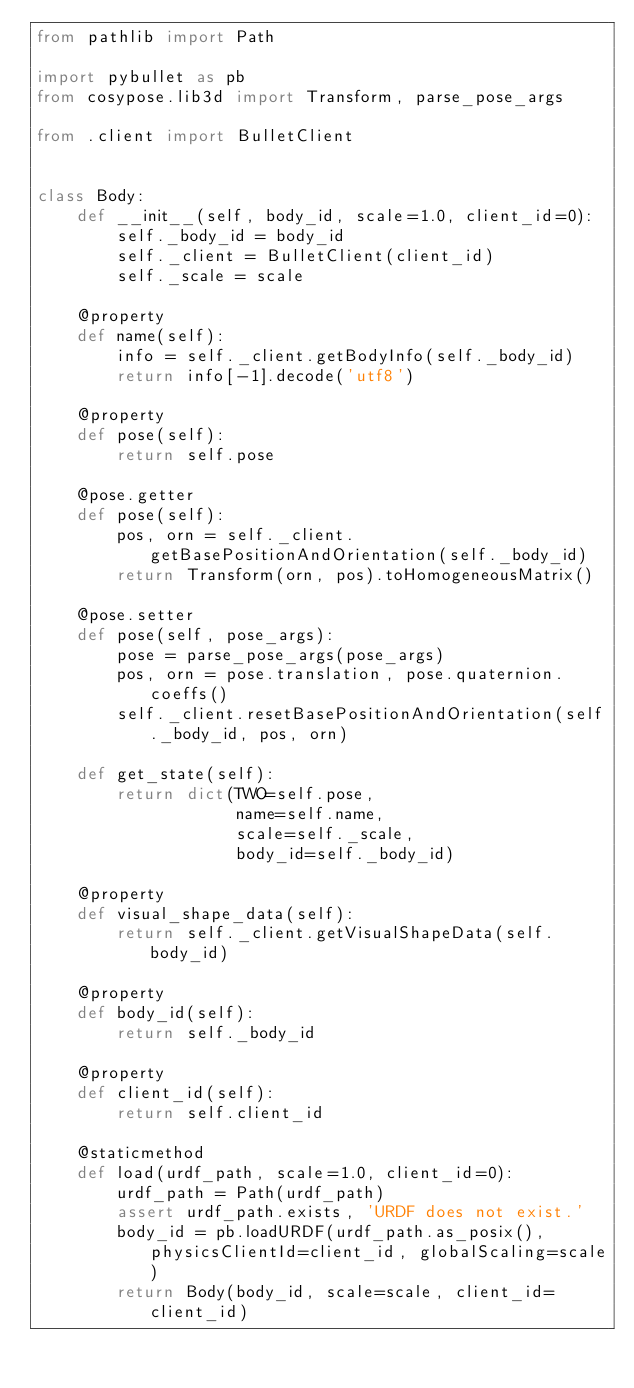<code> <loc_0><loc_0><loc_500><loc_500><_Python_>from pathlib import Path

import pybullet as pb
from cosypose.lib3d import Transform, parse_pose_args

from .client import BulletClient


class Body:
    def __init__(self, body_id, scale=1.0, client_id=0):
        self._body_id = body_id
        self._client = BulletClient(client_id)
        self._scale = scale

    @property
    def name(self):
        info = self._client.getBodyInfo(self._body_id)
        return info[-1].decode('utf8')

    @property
    def pose(self):
        return self.pose

    @pose.getter
    def pose(self):
        pos, orn = self._client.getBasePositionAndOrientation(self._body_id)
        return Transform(orn, pos).toHomogeneousMatrix()

    @pose.setter
    def pose(self, pose_args):
        pose = parse_pose_args(pose_args)
        pos, orn = pose.translation, pose.quaternion.coeffs()
        self._client.resetBasePositionAndOrientation(self._body_id, pos, orn)

    def get_state(self):
        return dict(TWO=self.pose,
                    name=self.name,
                    scale=self._scale,
                    body_id=self._body_id)

    @property
    def visual_shape_data(self):
        return self._client.getVisualShapeData(self.body_id)

    @property
    def body_id(self):
        return self._body_id

    @property
    def client_id(self):
        return self.client_id

    @staticmethod
    def load(urdf_path, scale=1.0, client_id=0):
        urdf_path = Path(urdf_path)
        assert urdf_path.exists, 'URDF does not exist.'
        body_id = pb.loadURDF(urdf_path.as_posix(), physicsClientId=client_id, globalScaling=scale)
        return Body(body_id, scale=scale, client_id=client_id)
</code> 